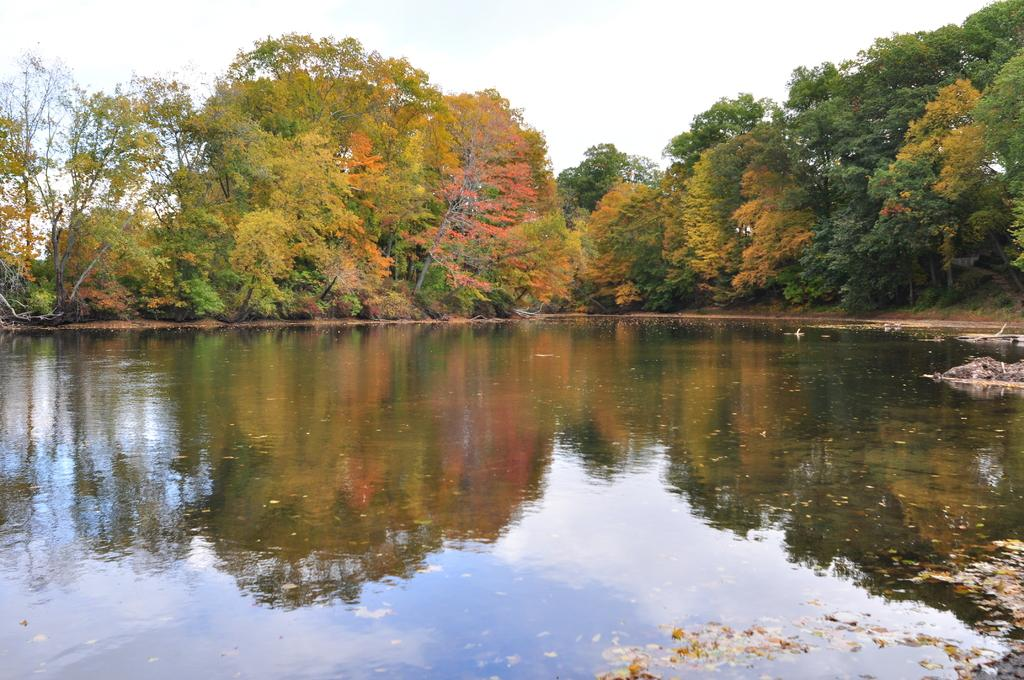What is visible in the image? Water is visible in the image. What can be seen in the background of the image? There are trees and the sky visible in the background of the image. What is reflected on the water's surface? The reflection of trees and the sky with clouds is visible on the water. How many cats are sitting on the side of the water in the image? There are no cats present in the image. 